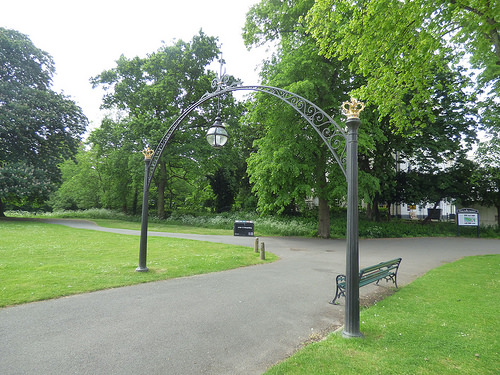<image>
Can you confirm if the bench is on the grass? No. The bench is not positioned on the grass. They may be near each other, but the bench is not supported by or resting on top of the grass. Where is the bench in relation to the grass? Is it under the grass? No. The bench is not positioned under the grass. The vertical relationship between these objects is different. 